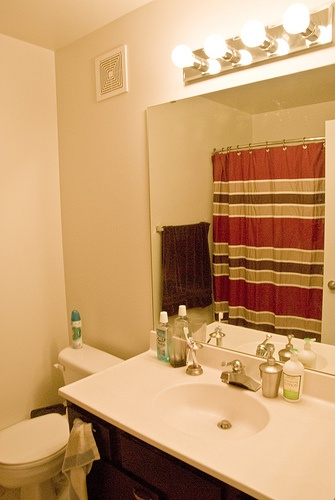Describe the objects in this image and their specific colors. I can see sink in tan and olive tones, toilet in tan and olive tones, bottle in tan and olive tones, bottle in tan, olive, and orange tones, and bottle in tan and olive tones in this image. 